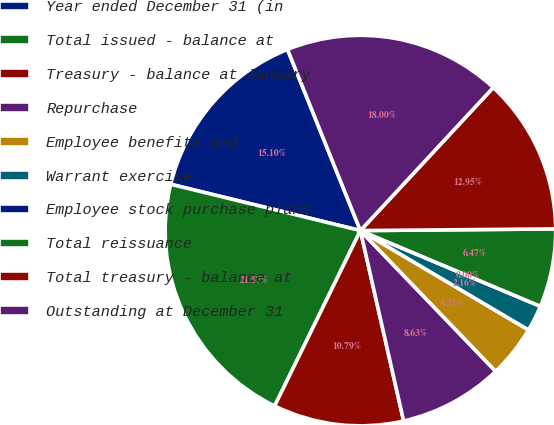Convert chart to OTSL. <chart><loc_0><loc_0><loc_500><loc_500><pie_chart><fcel>Year ended December 31 (in<fcel>Total issued - balance at<fcel>Treasury - balance at January<fcel>Repurchase<fcel>Employee benefits and<fcel>Warrant exercise<fcel>Employee stock purchase plans<fcel>Total reissuance<fcel>Total treasury - balance at<fcel>Outstanding at December 31<nl><fcel>15.1%<fcel>21.57%<fcel>10.79%<fcel>8.63%<fcel>4.32%<fcel>2.16%<fcel>0.0%<fcel>6.47%<fcel>12.95%<fcel>18.0%<nl></chart> 